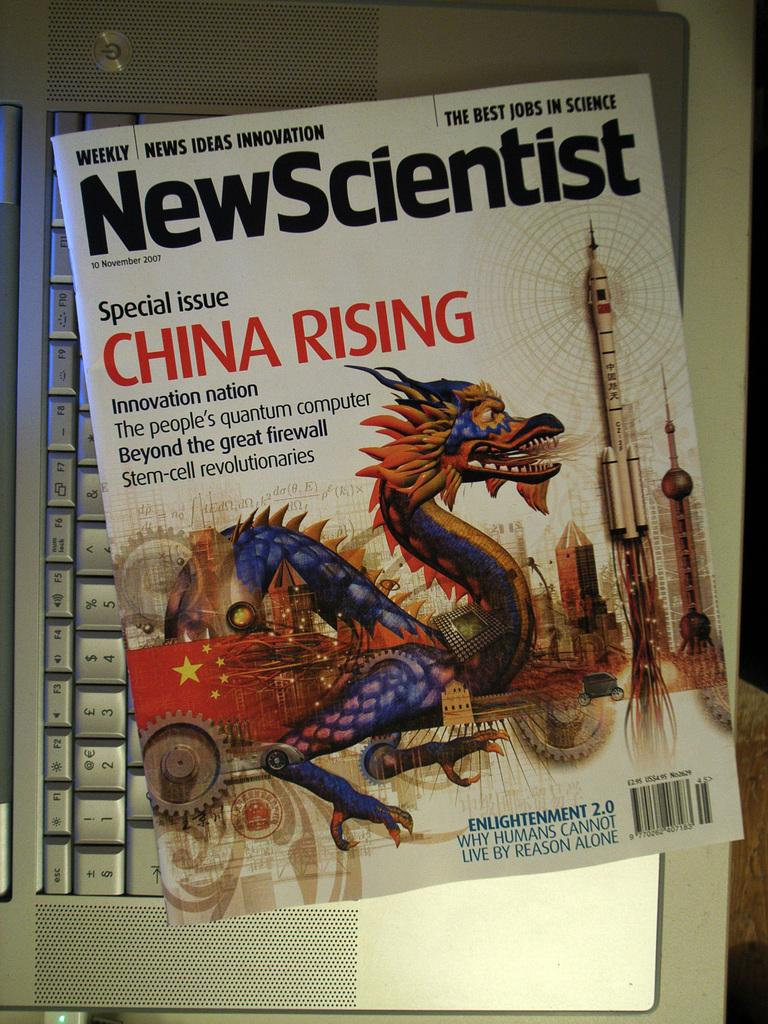<image>
Offer a succinct explanation of the picture presented. New Scientist Magazine that is a Special Issue in China Rising. 